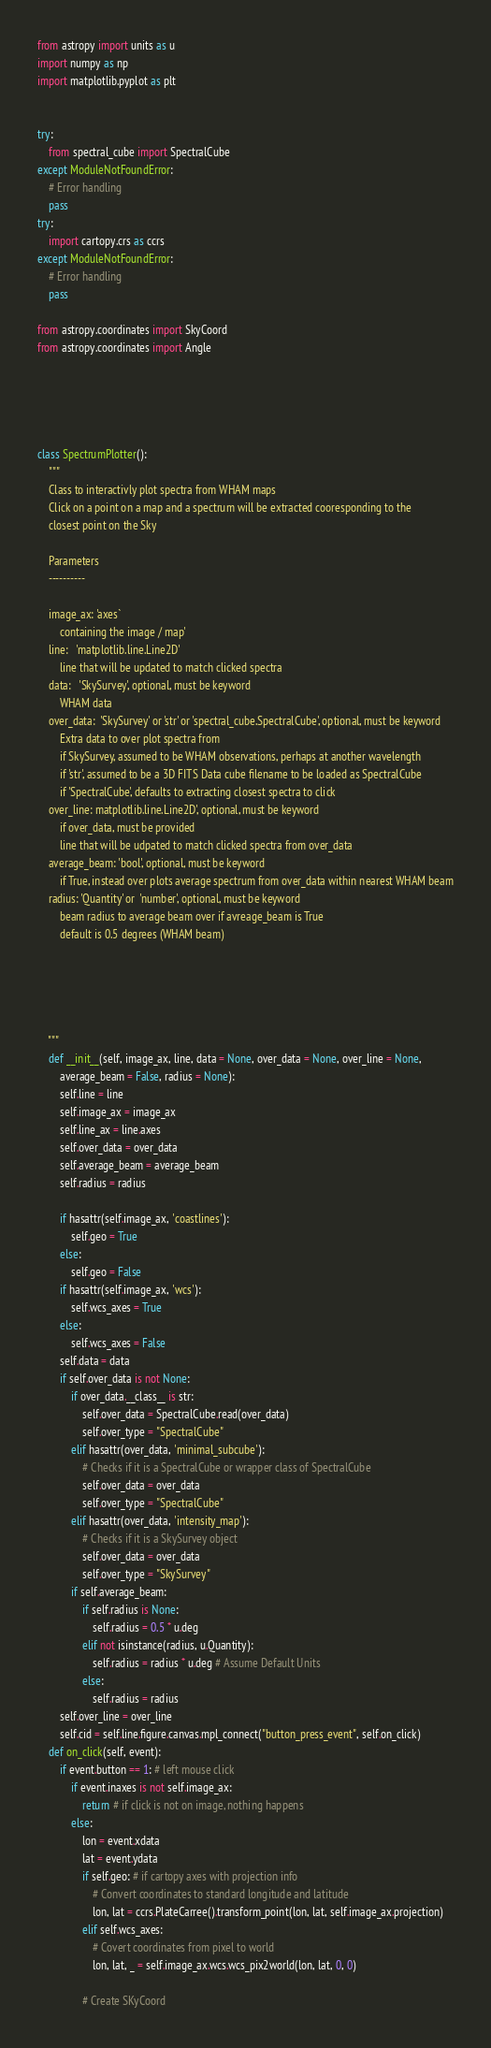<code> <loc_0><loc_0><loc_500><loc_500><_Python_>from astropy import units as u
import numpy as np 
import matplotlib.pyplot as plt


try:
    from spectral_cube import SpectralCube
except ModuleNotFoundError:
    # Error handling
    pass
try:
    import cartopy.crs as ccrs
except ModuleNotFoundError:
    # Error handling
    pass

from astropy.coordinates import SkyCoord
from astropy.coordinates import Angle





class SpectrumPlotter():
    """
    Class to interactivly plot spectra from WHAM maps
    Click on a point on a map and a spectrum will be extracted cooresponding to the 
    closest point on the Sky

    Parameters
    ----------

    image_ax: 'axes` 
        containing the image / map'
    line:   'matplotlib.line.Line2D'
        line that will be updated to match clicked spectra
    data:   'SkySurvey', optional, must be keyword
        WHAM data
    over_data:  'SkySurvey' or 'str' or 'spectral_cube.SpectralCube', optional, must be keyword
        Extra data to over plot spectra from
        if SkySurvey, assumed to be WHAM observations, perhaps at another wavelength
        if 'str', assumed to be a 3D FITS Data cube filename to be loaded as SpectralCube
        if 'SpectralCube', defaults to extracting closest spectra to click
    over_line: matplotlib.line.Line2D', optional, must be keyword
        if over_data, must be provided
        line that will be udpated to match clicked spectra from over_data
    average_beam: 'bool', optional, must be keyword
        if True, instead over plots average spectrum from over_data within nearest WHAM beam
    radius: 'Quantity' or  'number', optional, must be keyword
        beam radius to average beam over if avreage_beam is True
        default is 0.5 degrees (WHAM beam)





    """
    def __init__(self, image_ax, line, data = None, over_data = None, over_line = None, 
        average_beam = False, radius = None):
        self.line = line
        self.image_ax = image_ax
        self.line_ax = line.axes
        self.over_data = over_data
        self.average_beam = average_beam
        self.radius = radius

        if hasattr(self.image_ax, 'coastlines'):
            self.geo = True
        else:
            self.geo = False
        if hasattr(self.image_ax, 'wcs'):
            self.wcs_axes = True
        else:
            self.wcs_axes = False
        self.data = data
        if self.over_data is not None:
            if over_data.__class__ is str:
                self.over_data = SpectralCube.read(over_data)
                self.over_type = "SpectralCube"
            elif hasattr(over_data, 'minimal_subcube'):
                # Checks if it is a SpectralCube or wrapper class of SpectralCube
                self.over_data = over_data
                self.over_type = "SpectralCube"
            elif hasattr(over_data, 'intensity_map'):
                # Checks if it is a SkySurvey object
                self.over_data = over_data
                self.over_type = "SkySurvey"
            if self.average_beam:
                if self.radius is None:
                    self.radius = 0.5 * u.deg
                elif not isinstance(radius, u.Quantity):
                    self.radius = radius * u.deg # Assume Default Units
                else:
                    self.radius = radius
        self.over_line = over_line
        self.cid = self.line.figure.canvas.mpl_connect("button_press_event", self.on_click)
    def on_click(self, event):
        if event.button == 1: # left mouse click
            if event.inaxes is not self.image_ax: 
                return # if click is not on image, nothing happens
            else:
                lon = event.xdata
                lat = event.ydata
                if self.geo: # if cartopy axes with projection info
                    # Convert coordinates to standard longitude and latitude
                    lon, lat = ccrs.PlateCarree().transform_point(lon, lat, self.image_ax.projection)
                elif self.wcs_axes:
                    # Covert coordinates from pixel to world
                    lon, lat, _ = self.image_ax.wcs.wcs_pix2world(lon, lat, 0, 0)

                # Create SKyCoord</code> 